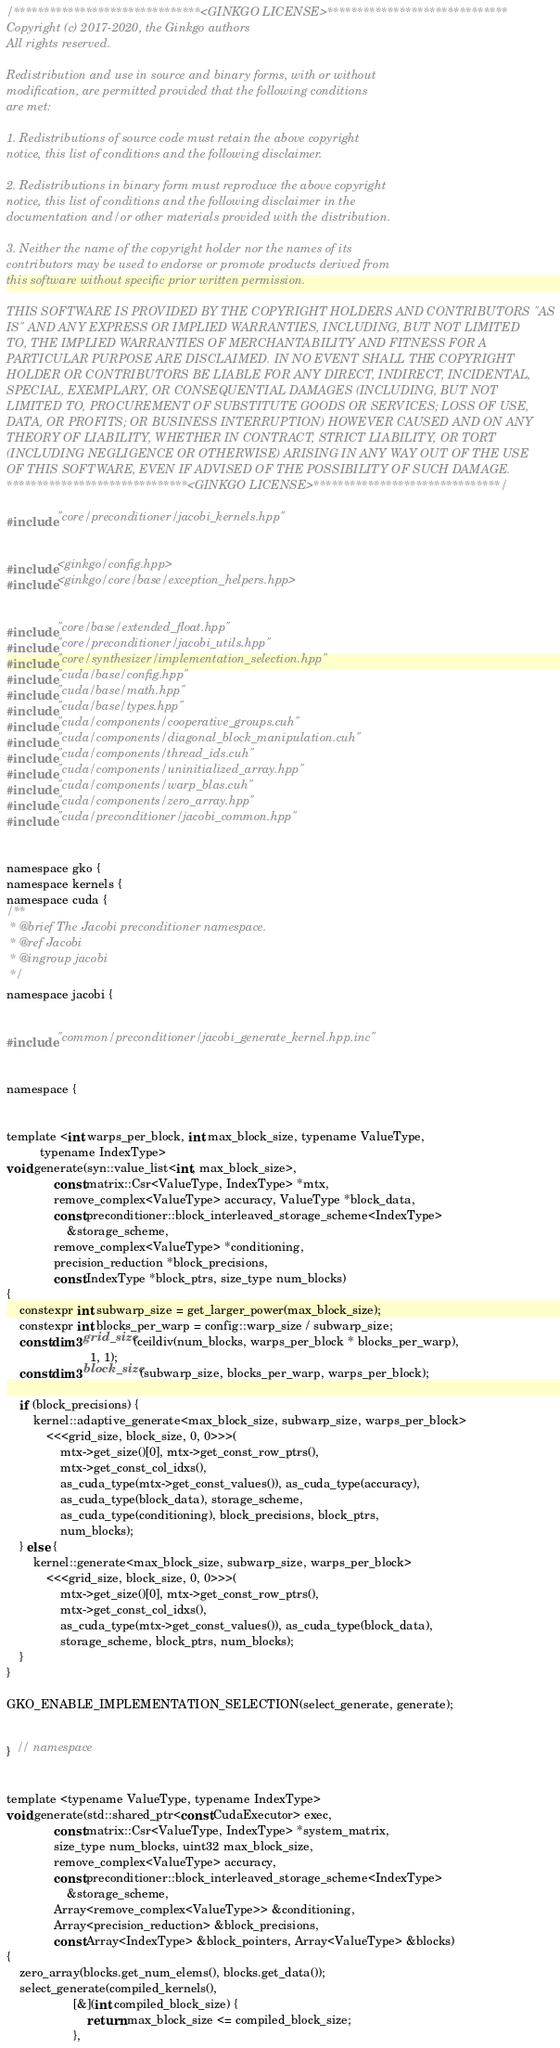<code> <loc_0><loc_0><loc_500><loc_500><_Cuda_>/*******************************<GINKGO LICENSE>******************************
Copyright (c) 2017-2020, the Ginkgo authors
All rights reserved.

Redistribution and use in source and binary forms, with or without
modification, are permitted provided that the following conditions
are met:

1. Redistributions of source code must retain the above copyright
notice, this list of conditions and the following disclaimer.

2. Redistributions in binary form must reproduce the above copyright
notice, this list of conditions and the following disclaimer in the
documentation and/or other materials provided with the distribution.

3. Neither the name of the copyright holder nor the names of its
contributors may be used to endorse or promote products derived from
this software without specific prior written permission.

THIS SOFTWARE IS PROVIDED BY THE COPYRIGHT HOLDERS AND CONTRIBUTORS "AS
IS" AND ANY EXPRESS OR IMPLIED WARRANTIES, INCLUDING, BUT NOT LIMITED
TO, THE IMPLIED WARRANTIES OF MERCHANTABILITY AND FITNESS FOR A
PARTICULAR PURPOSE ARE DISCLAIMED. IN NO EVENT SHALL THE COPYRIGHT
HOLDER OR CONTRIBUTORS BE LIABLE FOR ANY DIRECT, INDIRECT, INCIDENTAL,
SPECIAL, EXEMPLARY, OR CONSEQUENTIAL DAMAGES (INCLUDING, BUT NOT
LIMITED TO, PROCUREMENT OF SUBSTITUTE GOODS OR SERVICES; LOSS OF USE,
DATA, OR PROFITS; OR BUSINESS INTERRUPTION) HOWEVER CAUSED AND ON ANY
THEORY OF LIABILITY, WHETHER IN CONTRACT, STRICT LIABILITY, OR TORT
(INCLUDING NEGLIGENCE OR OTHERWISE) ARISING IN ANY WAY OUT OF THE USE
OF THIS SOFTWARE, EVEN IF ADVISED OF THE POSSIBILITY OF SUCH DAMAGE.
******************************<GINKGO LICENSE>*******************************/

#include "core/preconditioner/jacobi_kernels.hpp"


#include <ginkgo/config.hpp>
#include <ginkgo/core/base/exception_helpers.hpp>


#include "core/base/extended_float.hpp"
#include "core/preconditioner/jacobi_utils.hpp"
#include "core/synthesizer/implementation_selection.hpp"
#include "cuda/base/config.hpp"
#include "cuda/base/math.hpp"
#include "cuda/base/types.hpp"
#include "cuda/components/cooperative_groups.cuh"
#include "cuda/components/diagonal_block_manipulation.cuh"
#include "cuda/components/thread_ids.cuh"
#include "cuda/components/uninitialized_array.hpp"
#include "cuda/components/warp_blas.cuh"
#include "cuda/components/zero_array.hpp"
#include "cuda/preconditioner/jacobi_common.hpp"


namespace gko {
namespace kernels {
namespace cuda {
/**
 * @brief The Jacobi preconditioner namespace.
 * @ref Jacobi
 * @ingroup jacobi
 */
namespace jacobi {


#include "common/preconditioner/jacobi_generate_kernel.hpp.inc"


namespace {


template <int warps_per_block, int max_block_size, typename ValueType,
          typename IndexType>
void generate(syn::value_list<int, max_block_size>,
              const matrix::Csr<ValueType, IndexType> *mtx,
              remove_complex<ValueType> accuracy, ValueType *block_data,
              const preconditioner::block_interleaved_storage_scheme<IndexType>
                  &storage_scheme,
              remove_complex<ValueType> *conditioning,
              precision_reduction *block_precisions,
              const IndexType *block_ptrs, size_type num_blocks)
{
    constexpr int subwarp_size = get_larger_power(max_block_size);
    constexpr int blocks_per_warp = config::warp_size / subwarp_size;
    const dim3 grid_size(ceildiv(num_blocks, warps_per_block * blocks_per_warp),
                         1, 1);
    const dim3 block_size(subwarp_size, blocks_per_warp, warps_per_block);

    if (block_precisions) {
        kernel::adaptive_generate<max_block_size, subwarp_size, warps_per_block>
            <<<grid_size, block_size, 0, 0>>>(
                mtx->get_size()[0], mtx->get_const_row_ptrs(),
                mtx->get_const_col_idxs(),
                as_cuda_type(mtx->get_const_values()), as_cuda_type(accuracy),
                as_cuda_type(block_data), storage_scheme,
                as_cuda_type(conditioning), block_precisions, block_ptrs,
                num_blocks);
    } else {
        kernel::generate<max_block_size, subwarp_size, warps_per_block>
            <<<grid_size, block_size, 0, 0>>>(
                mtx->get_size()[0], mtx->get_const_row_ptrs(),
                mtx->get_const_col_idxs(),
                as_cuda_type(mtx->get_const_values()), as_cuda_type(block_data),
                storage_scheme, block_ptrs, num_blocks);
    }
}

GKO_ENABLE_IMPLEMENTATION_SELECTION(select_generate, generate);


}  // namespace


template <typename ValueType, typename IndexType>
void generate(std::shared_ptr<const CudaExecutor> exec,
              const matrix::Csr<ValueType, IndexType> *system_matrix,
              size_type num_blocks, uint32 max_block_size,
              remove_complex<ValueType> accuracy,
              const preconditioner::block_interleaved_storage_scheme<IndexType>
                  &storage_scheme,
              Array<remove_complex<ValueType>> &conditioning,
              Array<precision_reduction> &block_precisions,
              const Array<IndexType> &block_pointers, Array<ValueType> &blocks)
{
    zero_array(blocks.get_num_elems(), blocks.get_data());
    select_generate(compiled_kernels(),
                    [&](int compiled_block_size) {
                        return max_block_size <= compiled_block_size;
                    },</code> 